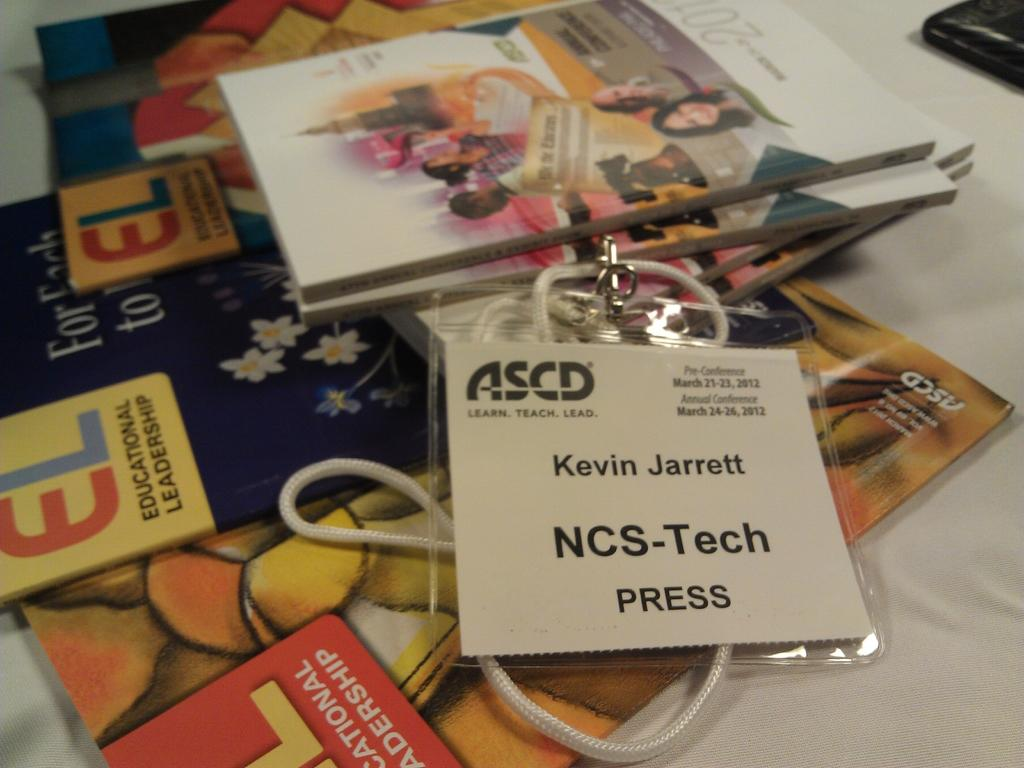<image>
Write a terse but informative summary of the picture. An ASCD Press badge belongs to NCS-Tech Kevin Jarrett. 